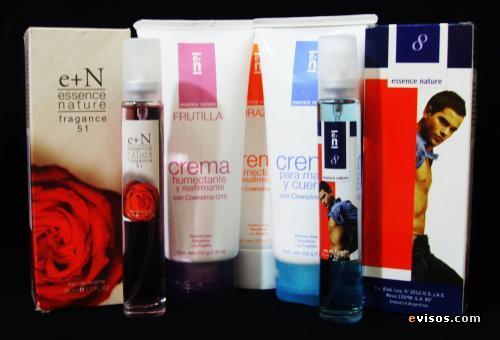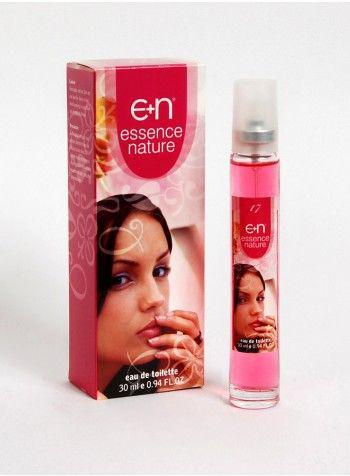The first image is the image on the left, the second image is the image on the right. Examine the images to the left and right. Is the description "There is only one tube of product and its box in the image on the left." accurate? Answer yes or no. No. The first image is the image on the left, the second image is the image on the right. Given the left and right images, does the statement "In one image, a single slender spray bottle stands next to a box with a woman's face on it." hold true? Answer yes or no. Yes. 